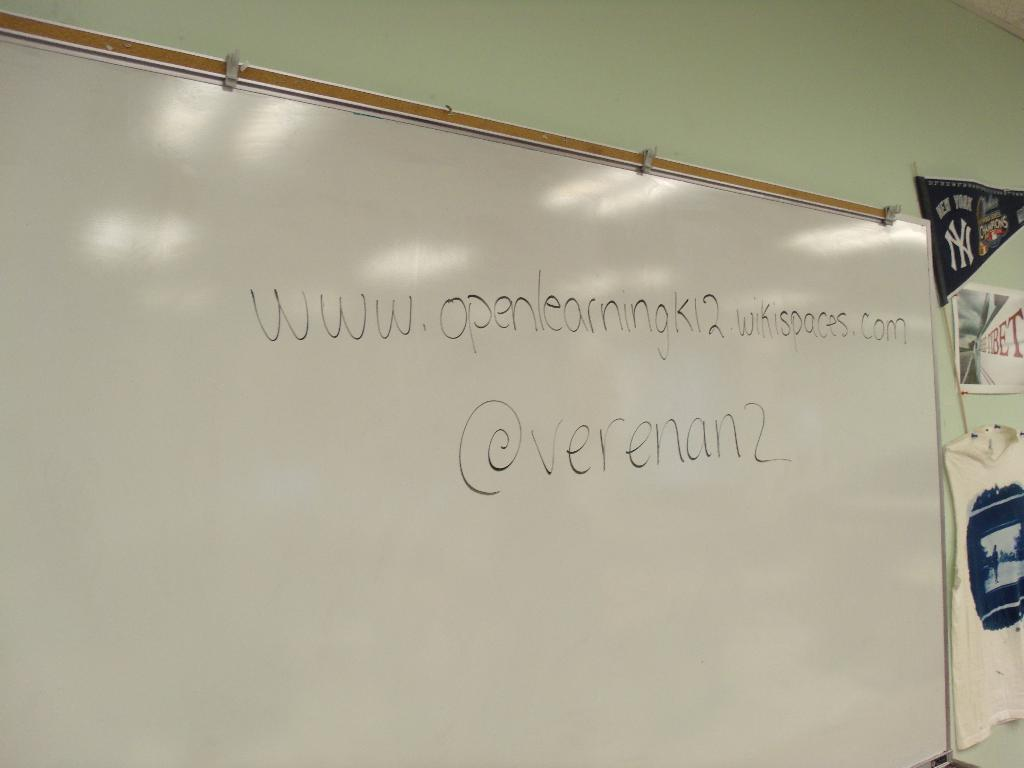<image>
Offer a succinct explanation of the picture presented. a white board with black writing from @verenan2 